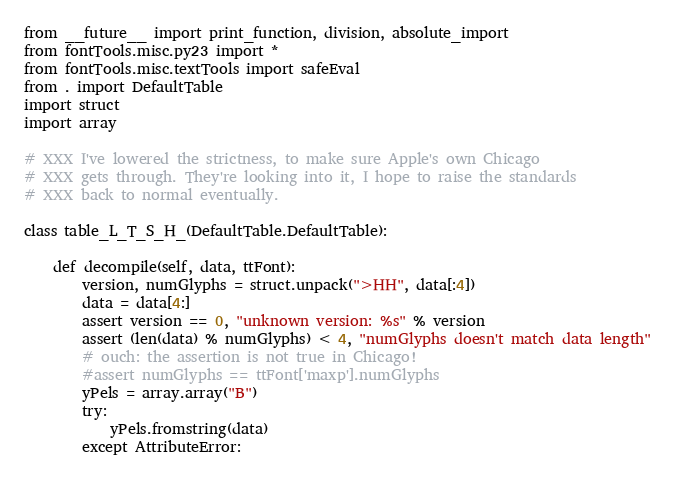Convert code to text. <code><loc_0><loc_0><loc_500><loc_500><_Python_>from __future__ import print_function, division, absolute_import
from fontTools.misc.py23 import *
from fontTools.misc.textTools import safeEval
from . import DefaultTable
import struct
import array

# XXX I've lowered the strictness, to make sure Apple's own Chicago
# XXX gets through. They're looking into it, I hope to raise the standards
# XXX back to normal eventually.

class table_L_T_S_H_(DefaultTable.DefaultTable):

	def decompile(self, data, ttFont):
		version, numGlyphs = struct.unpack(">HH", data[:4])
		data = data[4:]
		assert version == 0, "unknown version: %s" % version
		assert (len(data) % numGlyphs) < 4, "numGlyphs doesn't match data length"
		# ouch: the assertion is not true in Chicago!
		#assert numGlyphs == ttFont['maxp'].numGlyphs
		yPels = array.array("B")
		try:
			yPels.fromstring(data)
		except AttributeError:</code> 